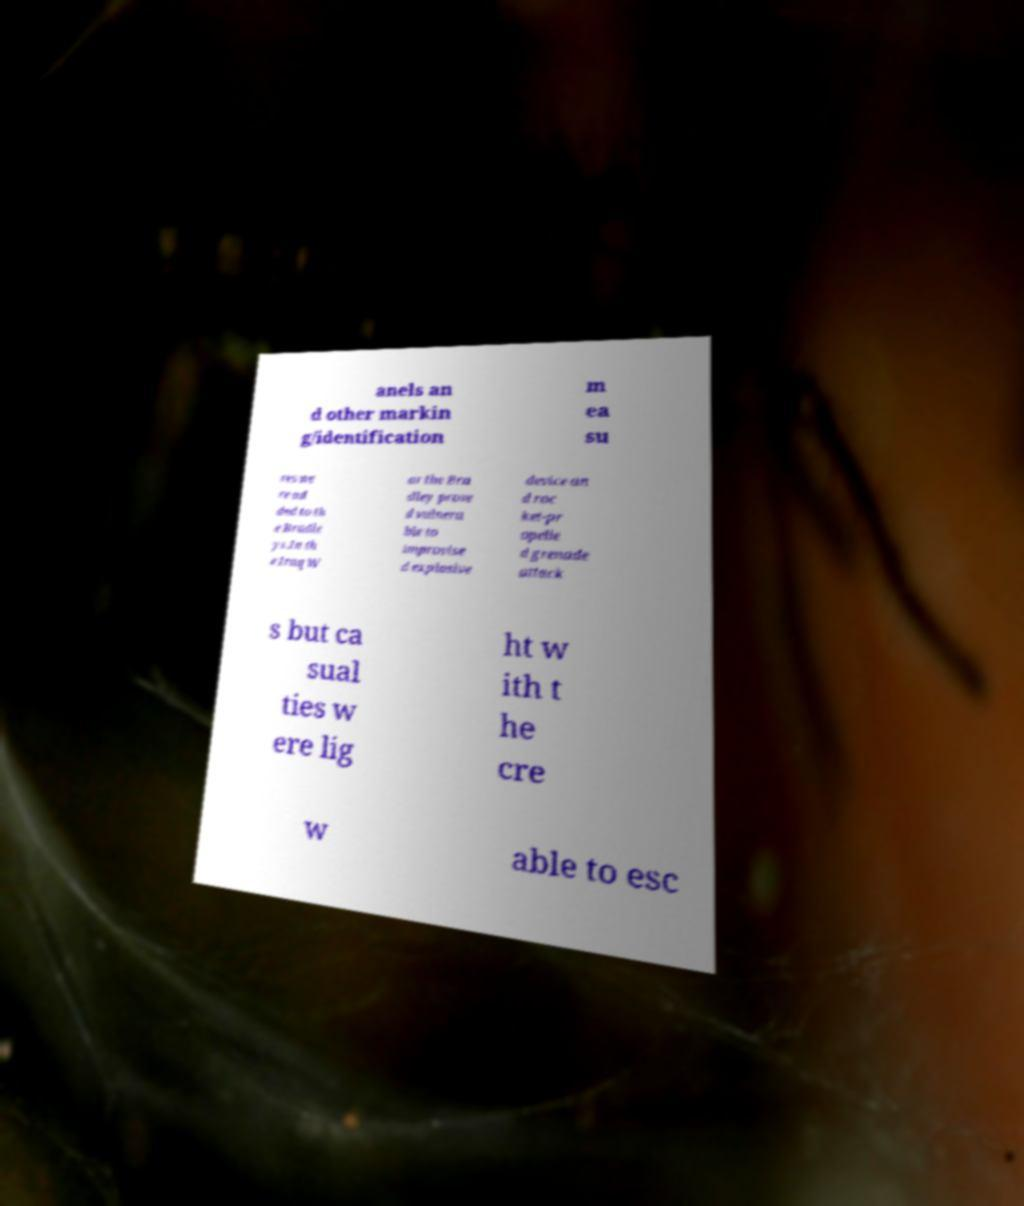Please read and relay the text visible in this image. What does it say? anels an d other markin g/identification m ea su res we re ad ded to th e Bradle ys.In th e Iraq W ar the Bra dley prove d vulnera ble to improvise d explosive device an d roc ket-pr opelle d grenade attack s but ca sual ties w ere lig ht w ith t he cre w able to esc 